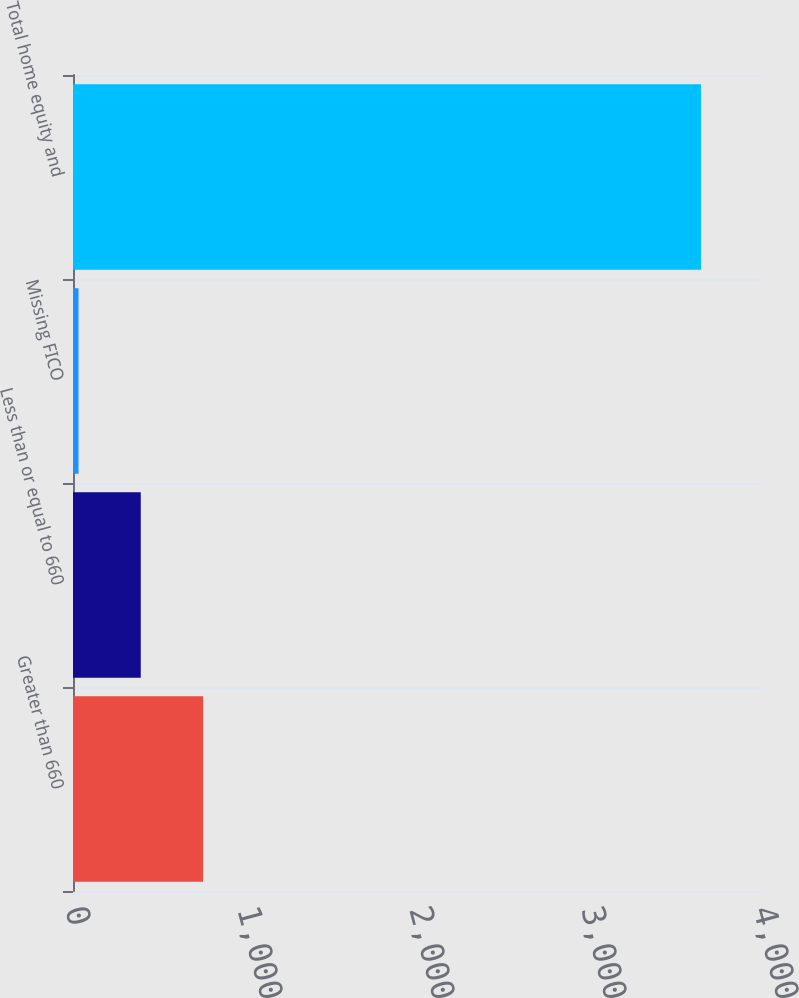Convert chart to OTSL. <chart><loc_0><loc_0><loc_500><loc_500><bar_chart><fcel>Greater than 660<fcel>Less than or equal to 660<fcel>Missing FICO<fcel>Total home equity and<nl><fcel>755.8<fcel>393.9<fcel>32<fcel>3651<nl></chart> 